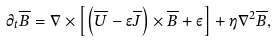<formula> <loc_0><loc_0><loc_500><loc_500>\partial _ { t } \overline { B } = \nabla \times \left [ \left ( \overline { U } - \epsilon \overline { J } \right ) \times \overline { B } + \varepsilon \right ] + \eta \nabla ^ { 2 } \overline { B } ,</formula> 